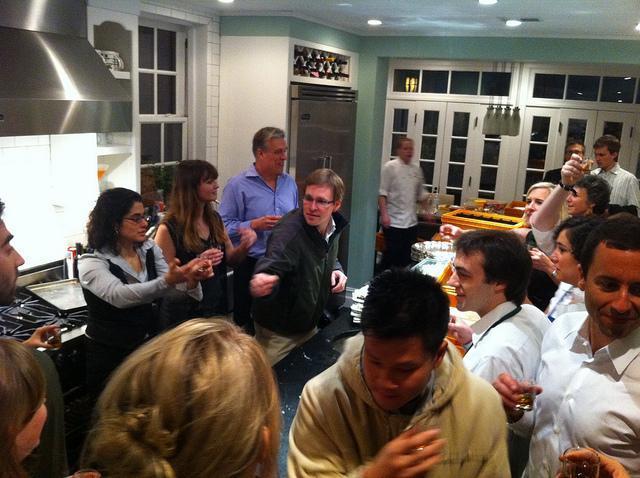How many people are in the photo?
Give a very brief answer. 11. How many people are holding a remote controller?
Give a very brief answer. 0. 